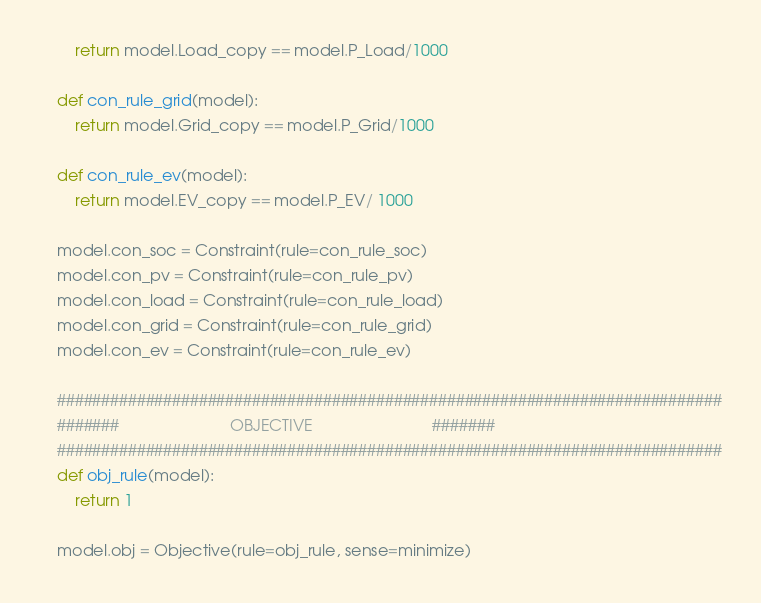<code> <loc_0><loc_0><loc_500><loc_500><_Python_>		return model.Load_copy == model.P_Load/1000

	def con_rule_grid(model):
		return model.Grid_copy == model.P_Grid/1000

	def con_rule_ev(model):
		return model.EV_copy == model.P_EV/ 1000

	model.con_soc = Constraint(rule=con_rule_soc)
	model.con_pv = Constraint(rule=con_rule_pv)
	model.con_load = Constraint(rule=con_rule_load)
	model.con_grid = Constraint(rule=con_rule_grid)
	model.con_ev = Constraint(rule=con_rule_ev)

	###########################################################################
	#######                         OBJECTIVE                           #######
	###########################################################################
	def obj_rule(model):
		return 1

	model.obj = Objective(rule=obj_rule, sense=minimize)
</code> 